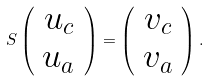<formula> <loc_0><loc_0><loc_500><loc_500>S \left ( \begin{array} { c } u _ { c } \\ u _ { a } \end{array} \right ) = \left ( \begin{array} { c } v _ { c } \\ v _ { a } \end{array} \right ) .</formula> 